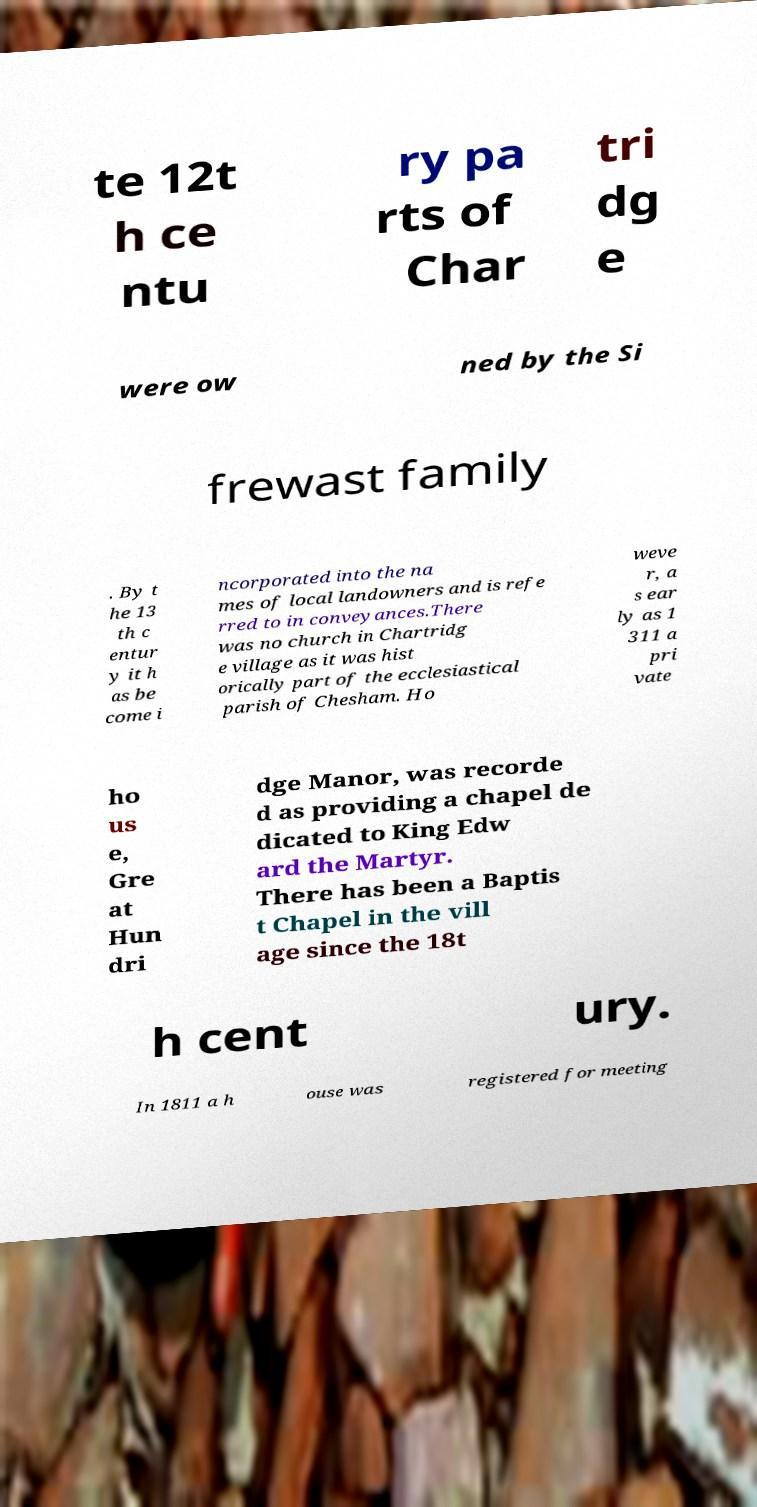I need the written content from this picture converted into text. Can you do that? te 12t h ce ntu ry pa rts of Char tri dg e were ow ned by the Si frewast family . By t he 13 th c entur y it h as be come i ncorporated into the na mes of local landowners and is refe rred to in conveyances.There was no church in Chartridg e village as it was hist orically part of the ecclesiastical parish of Chesham. Ho weve r, a s ear ly as 1 311 a pri vate ho us e, Gre at Hun dri dge Manor, was recorde d as providing a chapel de dicated to King Edw ard the Martyr. There has been a Baptis t Chapel in the vill age since the 18t h cent ury. In 1811 a h ouse was registered for meeting 